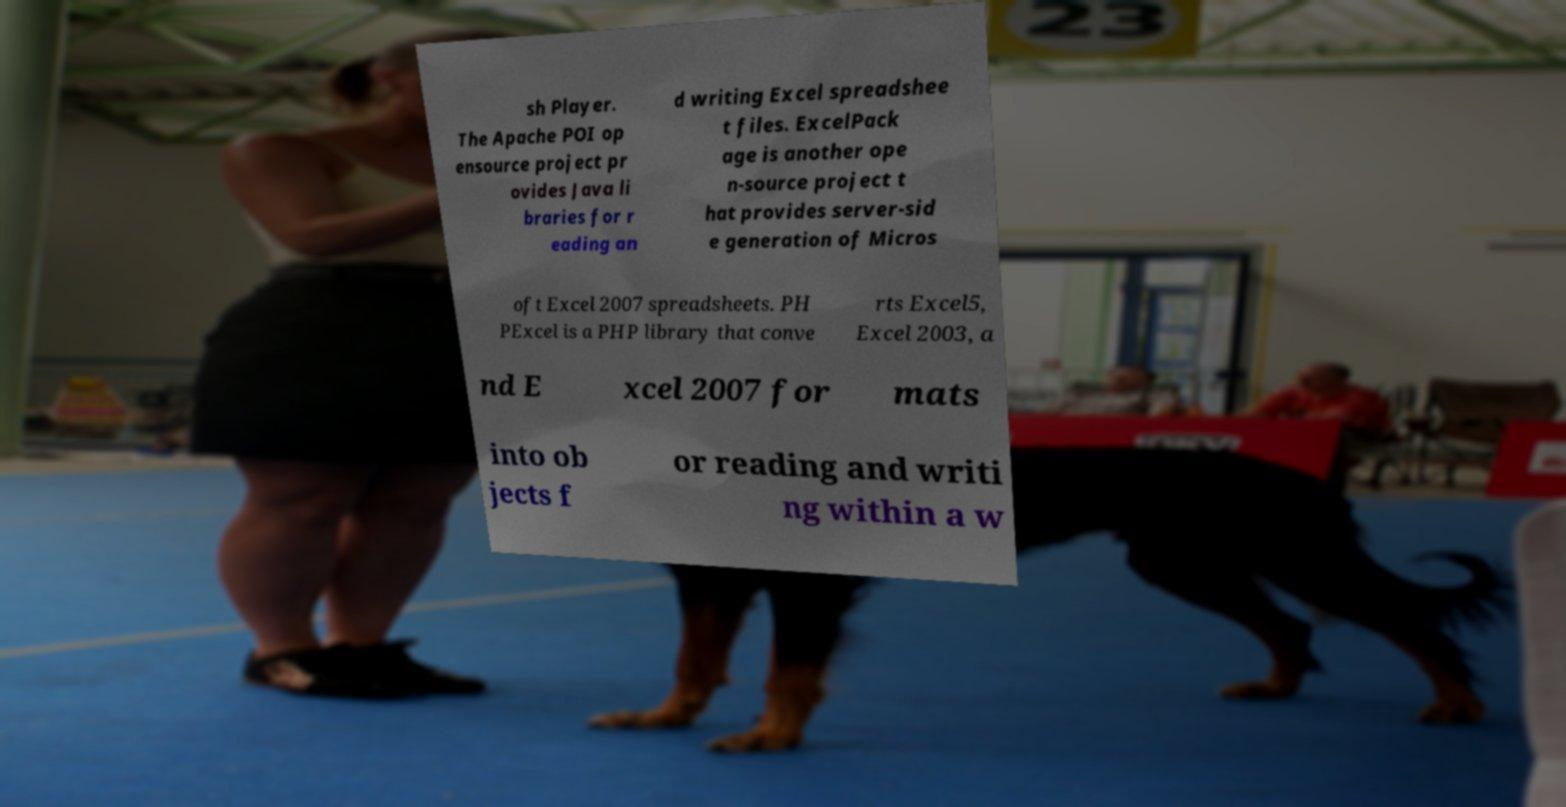Could you extract and type out the text from this image? sh Player. The Apache POI op ensource project pr ovides Java li braries for r eading an d writing Excel spreadshee t files. ExcelPack age is another ope n-source project t hat provides server-sid e generation of Micros oft Excel 2007 spreadsheets. PH PExcel is a PHP library that conve rts Excel5, Excel 2003, a nd E xcel 2007 for mats into ob jects f or reading and writi ng within a w 